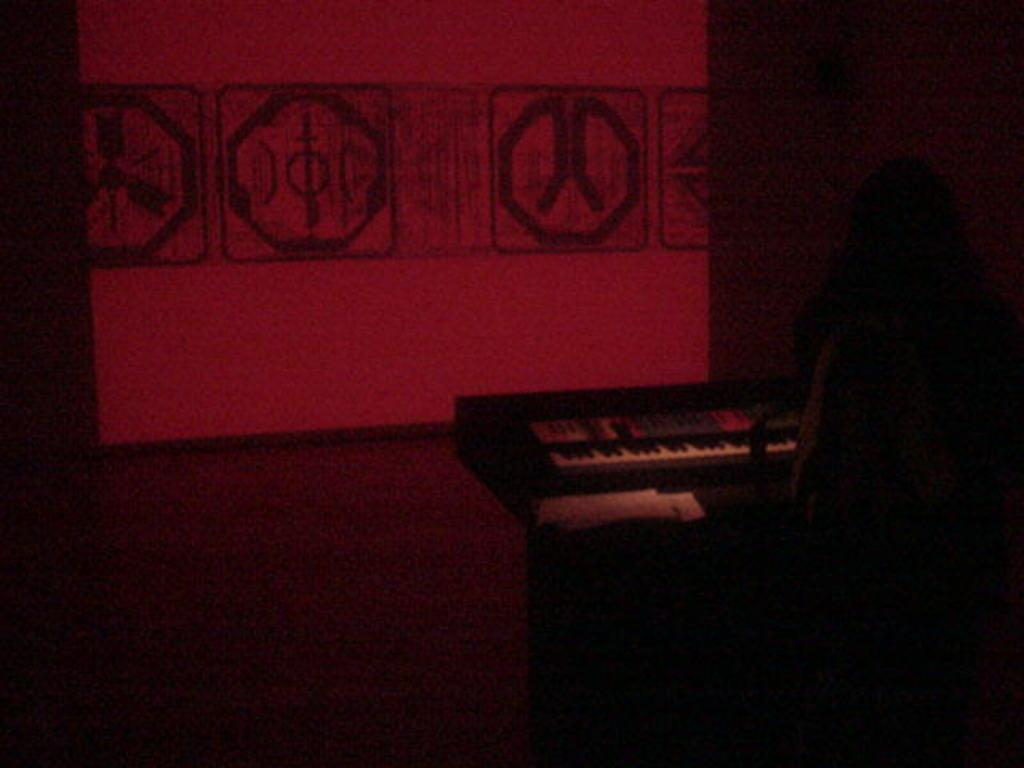What is the person in the image doing? The person is playing a musical instrument in the image. What type of musical instrument is the person playing? The person is playing a piano. What can be seen in the background of the image? There is a screen in the background of the image. What color is the car parked next to the piano in the image? There is no car present in the image; it only features a person playing a piano and a screen in the background. 